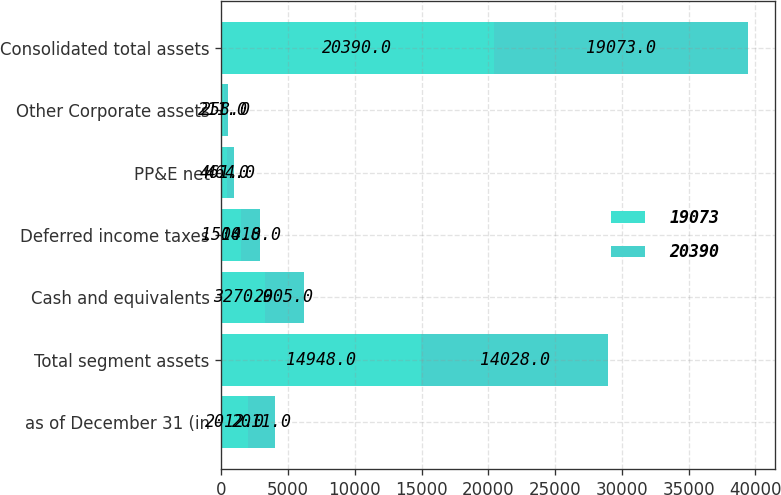<chart> <loc_0><loc_0><loc_500><loc_500><stacked_bar_chart><ecel><fcel>as of December 31 (in<fcel>Total segment assets<fcel>Cash and equivalents<fcel>Deferred income taxes<fcel>PP&E net<fcel>Other Corporate assets<fcel>Consolidated total assets<nl><fcel>19073<fcel>2012<fcel>14948<fcel>3270<fcel>1500<fcel>461<fcel>211<fcel>20390<nl><fcel>20390<fcel>2011<fcel>14028<fcel>2905<fcel>1418<fcel>464<fcel>258<fcel>19073<nl></chart> 